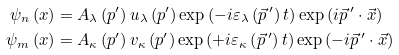Convert formula to latex. <formula><loc_0><loc_0><loc_500><loc_500>\psi _ { n } \left ( x \right ) & = A _ { \lambda } \left ( p ^ { \prime } \right ) u _ { \lambda } \left ( p ^ { \prime } \right ) \exp \left ( - i \varepsilon _ { \lambda } \left ( \vec { p } \, ^ { \prime } \right ) t \right ) \exp \left ( i \vec { p } \, ^ { \prime } \cdot \vec { x } \right ) \\ \psi _ { m } \left ( x \right ) & = A _ { \kappa } \left ( p ^ { \prime } \right ) v _ { \kappa } \left ( p ^ { \prime } \right ) \exp \left ( + i \varepsilon _ { \kappa } \left ( \vec { p } \, ^ { \prime } \right ) t \right ) \exp \left ( - i \vec { p } \, ^ { \prime } \cdot \vec { x } \right )</formula> 